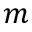<formula> <loc_0><loc_0><loc_500><loc_500>m</formula> 